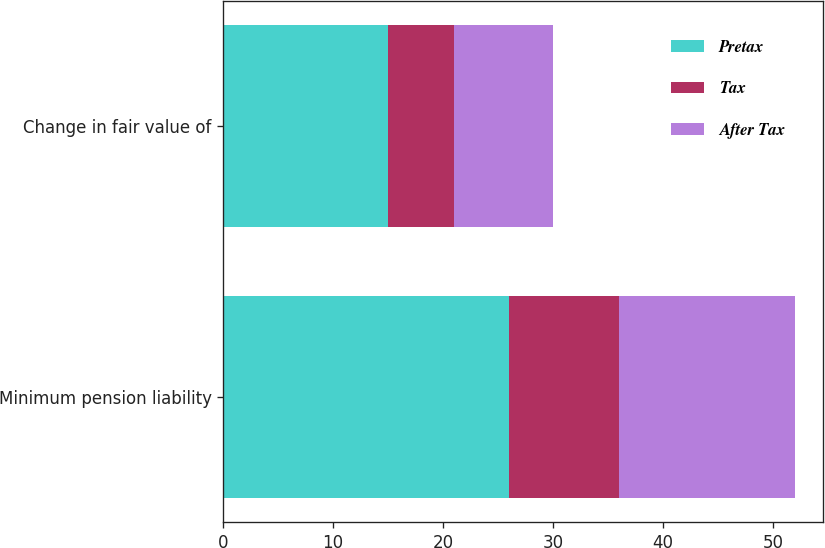Convert chart. <chart><loc_0><loc_0><loc_500><loc_500><stacked_bar_chart><ecel><fcel>Minimum pension liability<fcel>Change in fair value of<nl><fcel>Pretax<fcel>26<fcel>15<nl><fcel>Tax<fcel>10<fcel>6<nl><fcel>After Tax<fcel>16<fcel>9<nl></chart> 